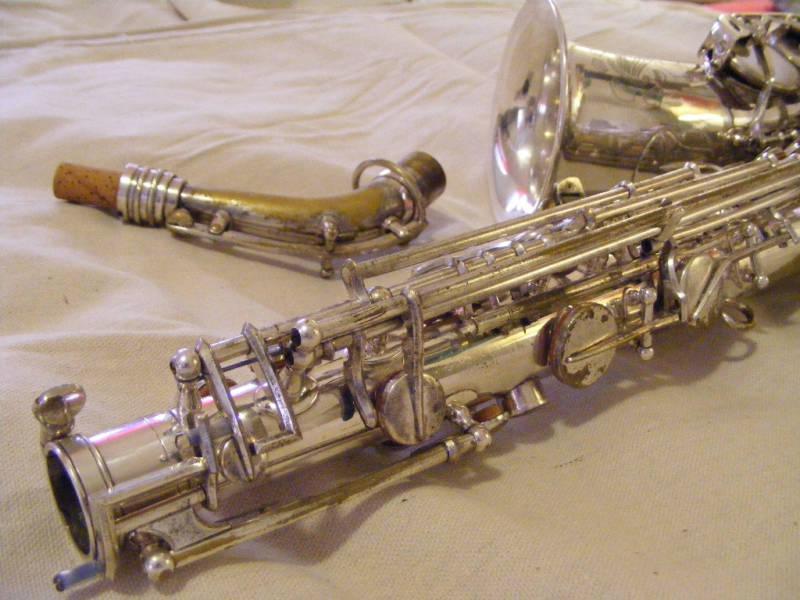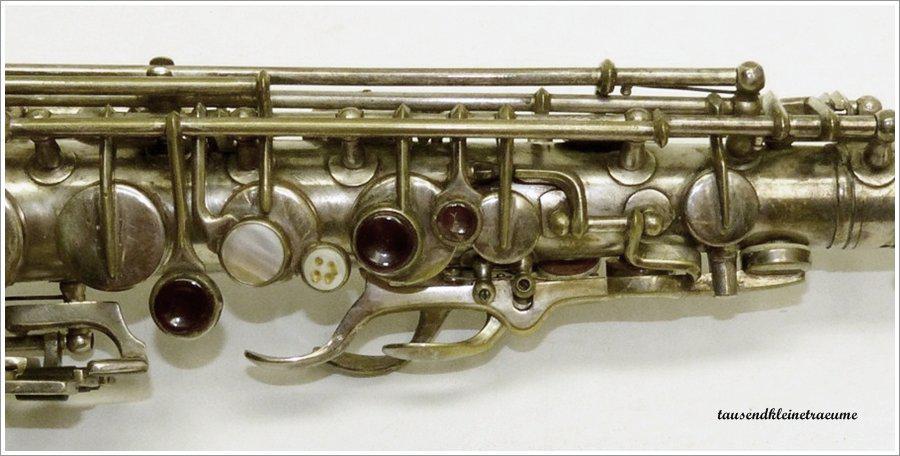The first image is the image on the left, the second image is the image on the right. Analyze the images presented: Is the assertion "The saxophone on the right side is on a black background." valid? Answer yes or no. No. The first image is the image on the left, the second image is the image on the right. Considering the images on both sides, is "there are two saxophones and one case in the pair of images." valid? Answer yes or no. No. 